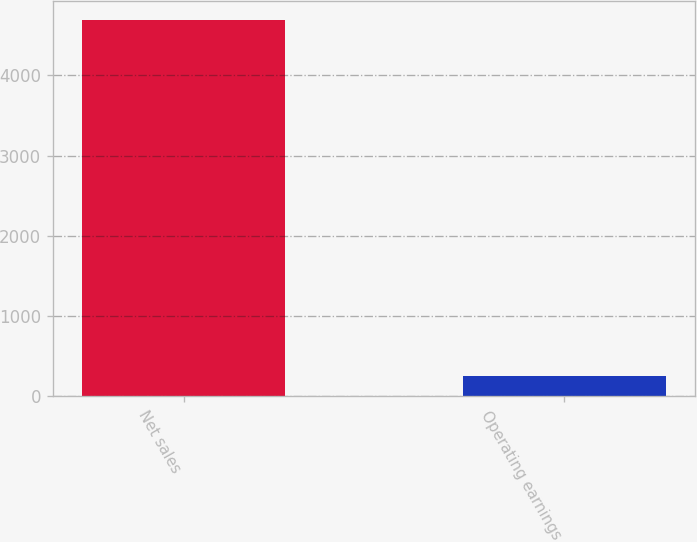Convert chart. <chart><loc_0><loc_0><loc_500><loc_500><bar_chart><fcel>Net sales<fcel>Operating earnings<nl><fcel>4695<fcel>249<nl></chart> 